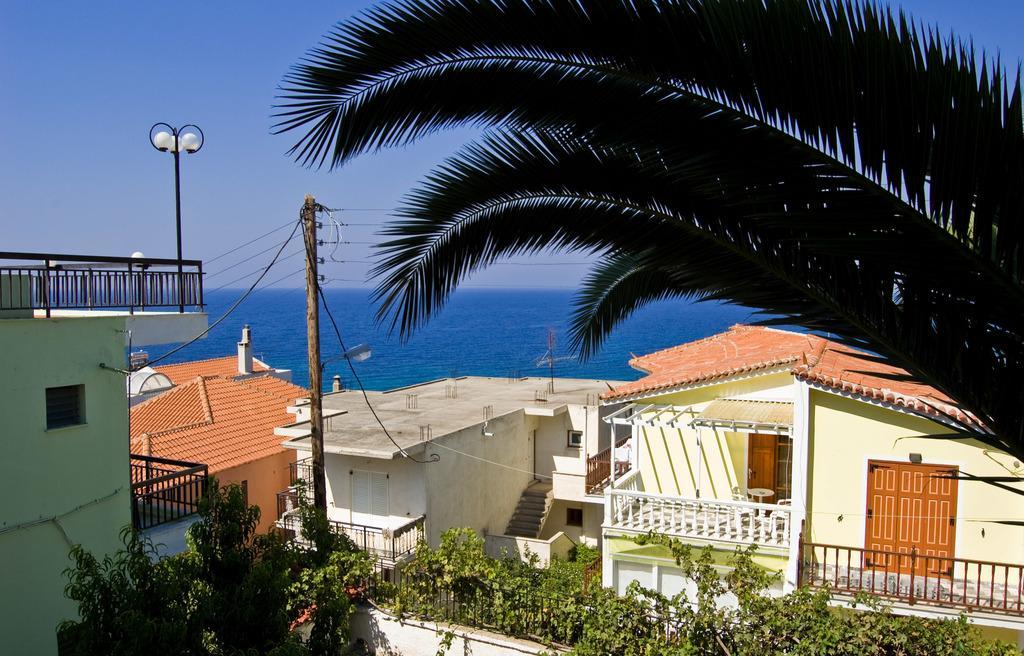In one or two sentences, can you explain what this image depicts? This is a picture of the city where there are buildings, plants, iron grills, trees, table, chairs, lights, poles, water,sky. 